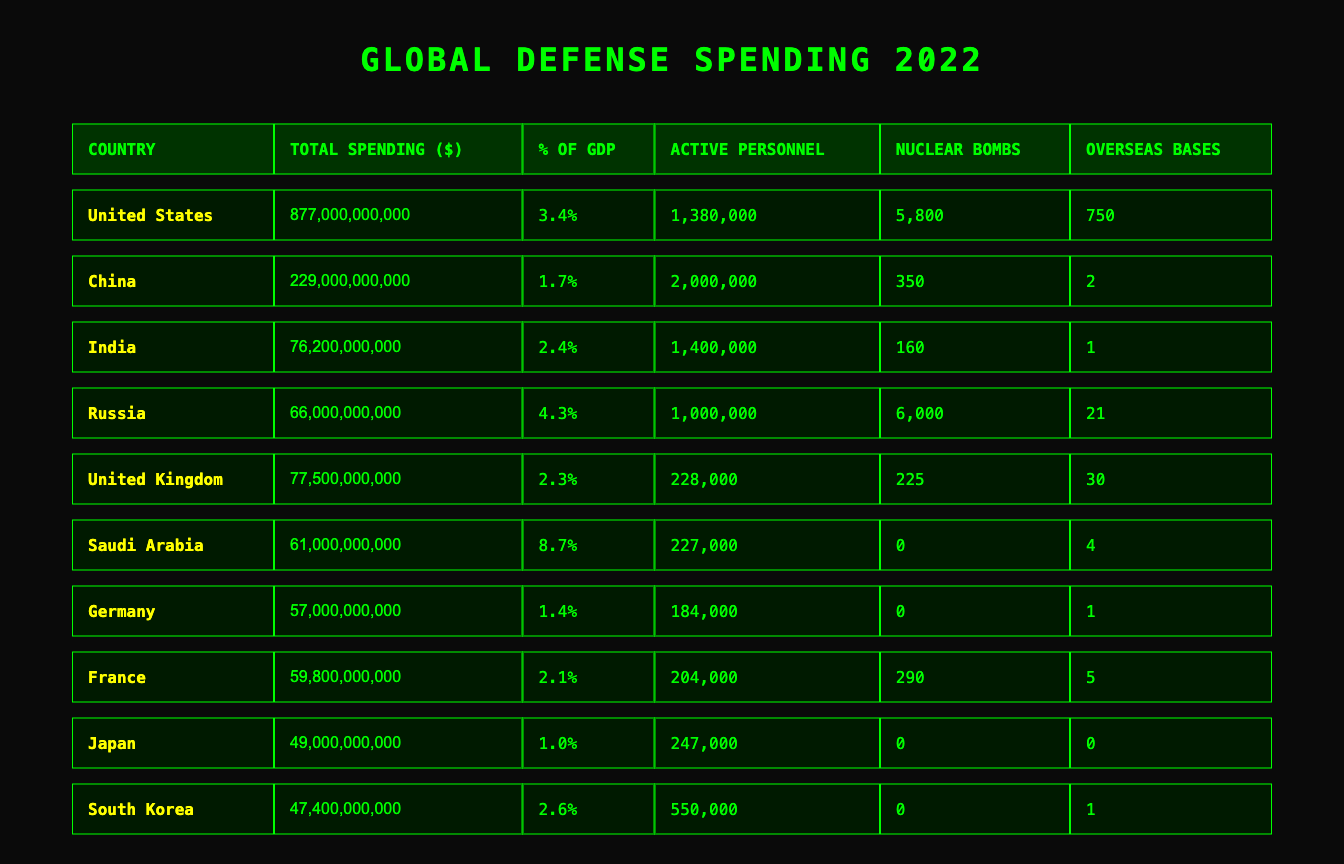What is the total defense spending of the United States? The table lists the total defense spending for each country. For the United States, the value is given as 877,000,000,000.
Answer: 877,000,000,000 Which country has the highest percentage of GDP spent on defense? The table shows the percentage of GDP used for defense by each country. Checking these values, Saudi Arabia has the highest at 8.7%.
Answer: Saudi Arabia How many active personnel does China have? The table indicates the number of active personnel for each country. For China, it states 2,000,000 active personnel.
Answer: 2,000,000 What is the difference in total defense spending between India and Russia? India's total spending is 76,200,000,000 and Russia's is 66,000,000,000. The difference is calculated by subtracting Russia's spending from India's: 76,200,000,000 - 66,000,000,000 = 10,200,000,000.
Answer: 10,200,000,000 Does Japan have any nuclear bombs? The table lists the number of nuclear bombs for each country. For Japan, it states 0 nuclear bombs.
Answer: No Which country has the most military bases overseas? The table provides the number of overseas military bases for each country. The United States has 750 military bases, which is the highest.
Answer: United States What is the total number of nuclear bombs held by the top three countries by military spending? The countries with the highest spending are the United States (5,800), China (350), and Russia (6,000). Adding these together: 5,800 + 350 + 6,000 = 12,150.
Answer: 12,150 Is the defense spending of India greater than that of Germany? India's spending is 76,200,000,000 and Germany's is 57,000,000,000. Since 76,200,000,000 is greater than 57,000,000,000, the statement is true.
Answer: Yes If we average the percentage of GDP spent on defense by the top five countries, what will it be? The percentages for the top five are: 3.4 (US), 1.7 (China), 2.4 (India), 4.3 (Russia), and 2.3 (UK). Adding them gives 14.1. Dividing by 5 gives an average of 2.82.
Answer: 2.82 How many active personnel do the countries with overseas military bases have combined? The countries with overseas bases are the United States (1,380,000), United Kingdom (228,000), Saudi Arabia (227,000), Russia (1,000,000), France (204,000), and South Korea (550,000). Summing these, we get: 1,380,000 + 228,000 + 227,000 + 1,000,000 + 204,000 + 550,000 = 3,589,000.
Answer: 3,589,000 What is the total defense spending of the countries that have no nuclear bombs? The countries without nuclear bombs are Germany, Japan, and South Korea. Their spending is 57,000,000,000 (Germany) + 49,000,000,000 (Japan) + 47,400,000,000 (South Korea) = 153,400,000,000.
Answer: 153,400,000,000 